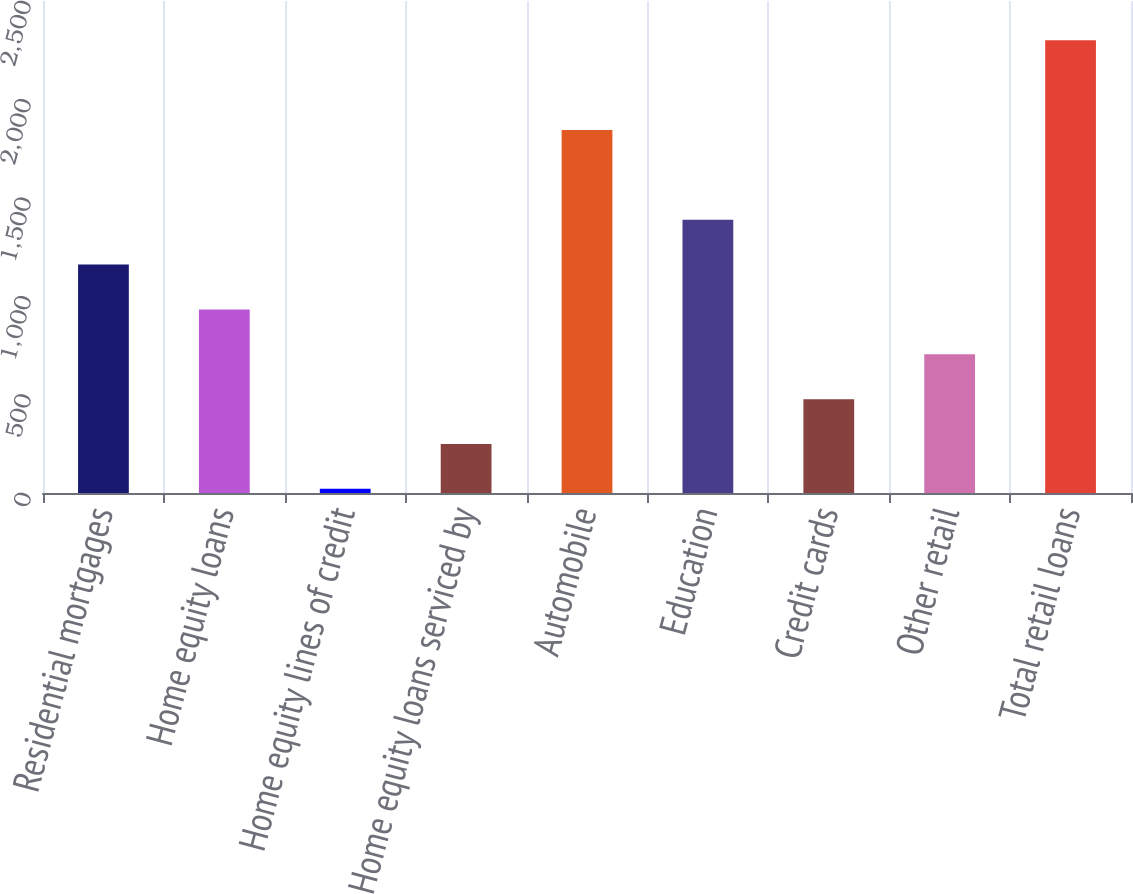Convert chart. <chart><loc_0><loc_0><loc_500><loc_500><bar_chart><fcel>Residential mortgages<fcel>Home equity loans<fcel>Home equity lines of credit<fcel>Home equity loans serviced by<fcel>Automobile<fcel>Education<fcel>Credit cards<fcel>Other retail<fcel>Total retail loans<nl><fcel>1161<fcel>933<fcel>21<fcel>249<fcel>1845<fcel>1389<fcel>477<fcel>705<fcel>2301<nl></chart> 